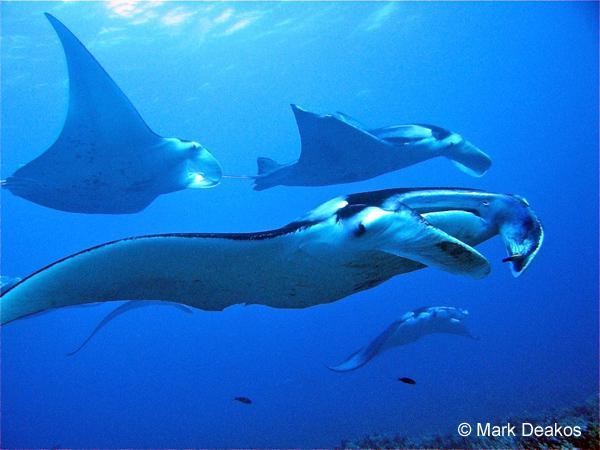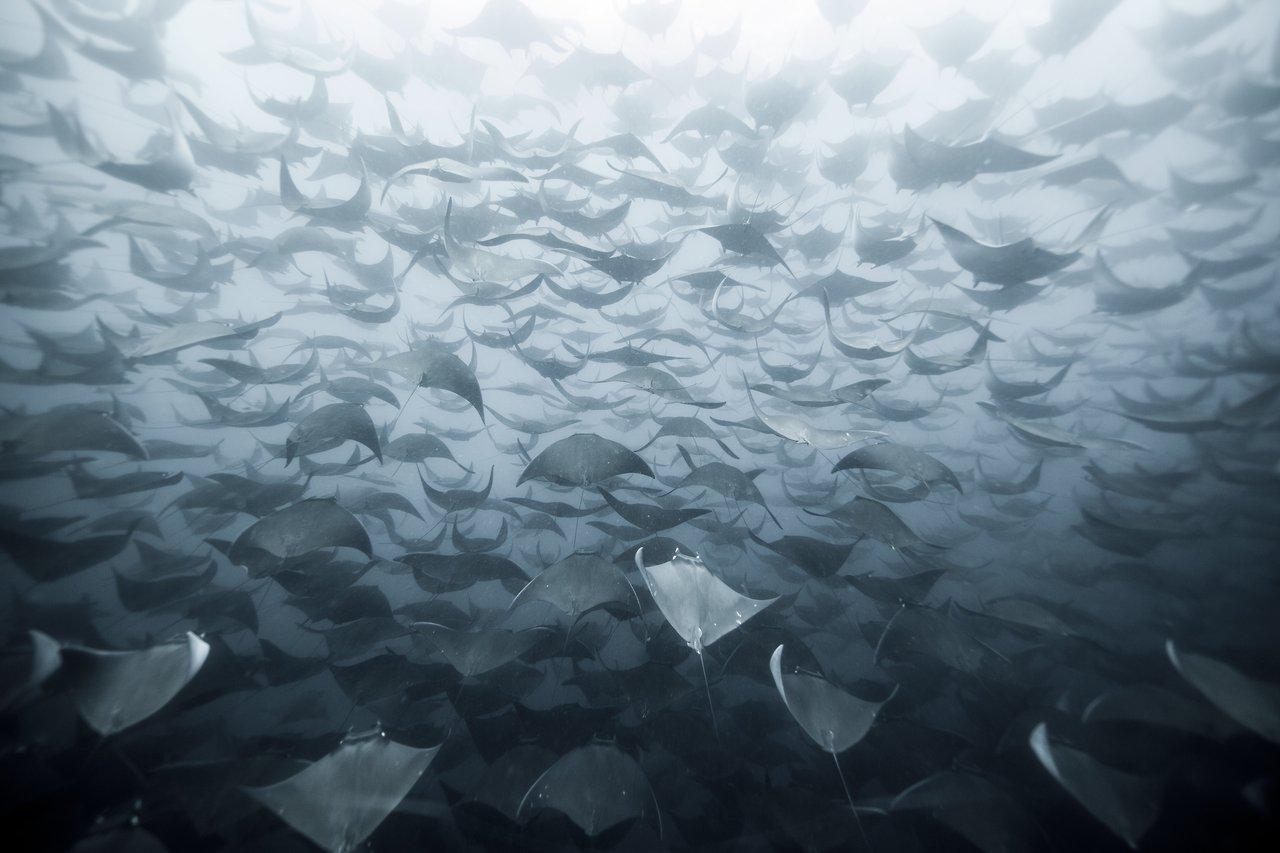The first image is the image on the left, the second image is the image on the right. Given the left and right images, does the statement "There is exactly one stingray in the image on the left." hold true? Answer yes or no. No. The first image is the image on the left, the second image is the image on the right. Assess this claim about the two images: "One image contains dozens of stingrays swimming close together.". Correct or not? Answer yes or no. Yes. 